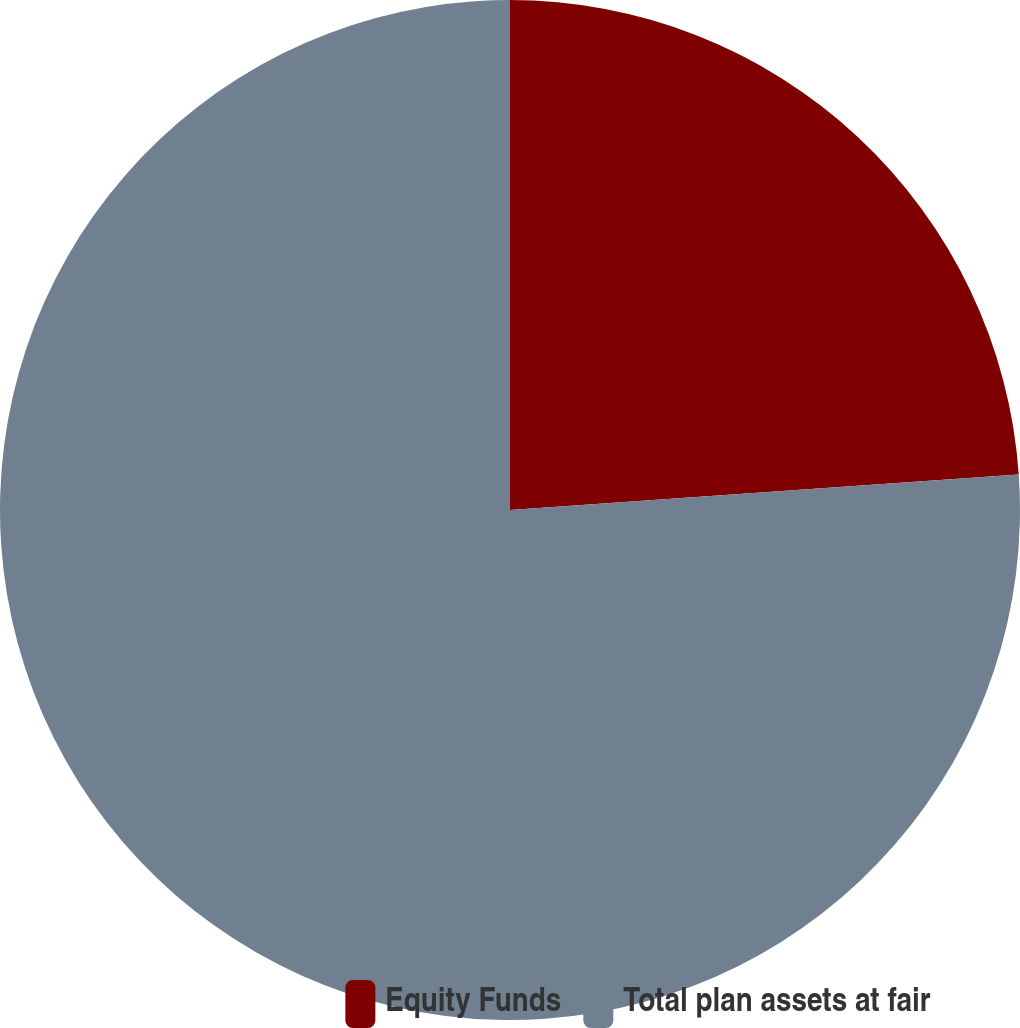Convert chart. <chart><loc_0><loc_0><loc_500><loc_500><pie_chart><fcel>Equity Funds<fcel>Total plan assets at fair<nl><fcel>23.89%<fcel>76.11%<nl></chart> 